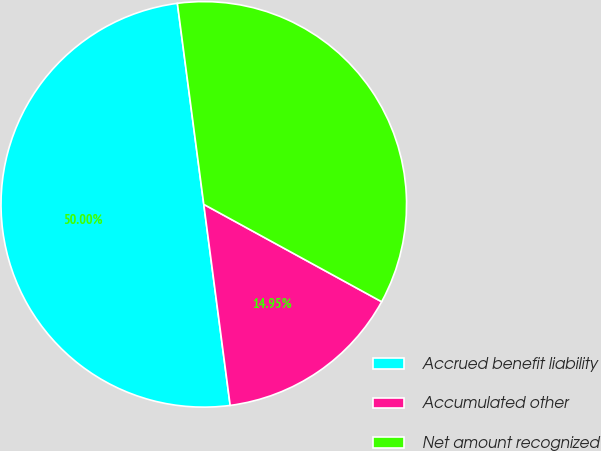<chart> <loc_0><loc_0><loc_500><loc_500><pie_chart><fcel>Accrued benefit liability<fcel>Accumulated other<fcel>Net amount recognized<nl><fcel>50.0%<fcel>14.95%<fcel>35.05%<nl></chart> 